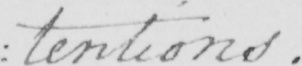Please transcribe the handwritten text in this image. : tentions . 